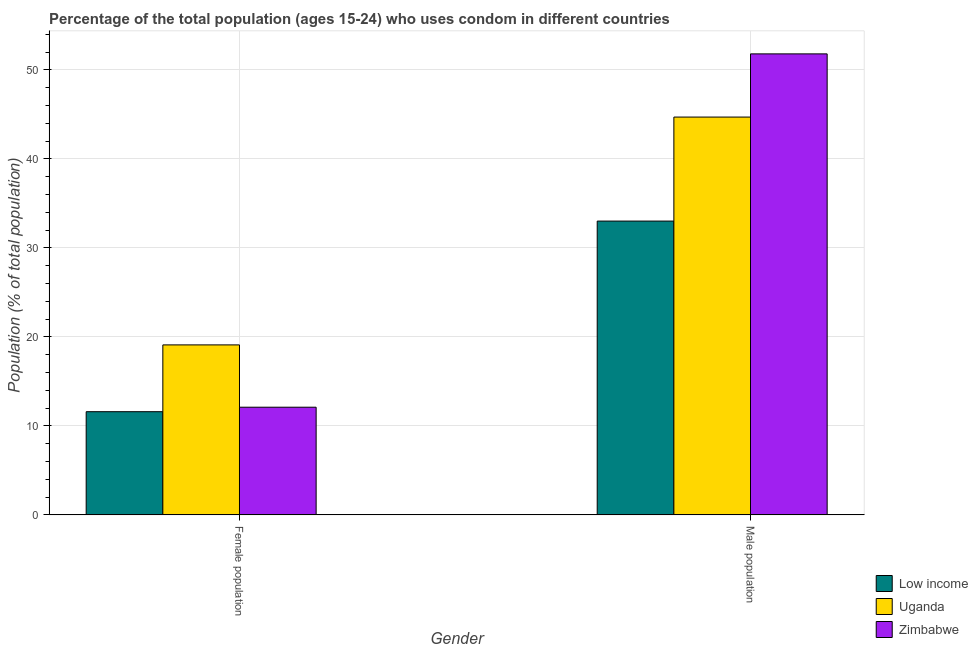How many groups of bars are there?
Your answer should be compact. 2. Are the number of bars on each tick of the X-axis equal?
Provide a succinct answer. Yes. How many bars are there on the 1st tick from the right?
Provide a short and direct response. 3. What is the label of the 1st group of bars from the left?
Offer a terse response. Female population. Across all countries, what is the maximum male population?
Make the answer very short. 51.8. Across all countries, what is the minimum female population?
Ensure brevity in your answer.  11.6. In which country was the male population maximum?
Provide a short and direct response. Zimbabwe. In which country was the male population minimum?
Provide a succinct answer. Low income. What is the total female population in the graph?
Give a very brief answer. 42.8. What is the difference between the female population in Low income and that in Zimbabwe?
Ensure brevity in your answer.  -0.5. What is the difference between the female population in Low income and the male population in Uganda?
Offer a very short reply. -33.1. What is the average female population per country?
Offer a terse response. 14.27. What is the difference between the female population and male population in Low income?
Ensure brevity in your answer.  -21.42. In how many countries, is the female population greater than 44 %?
Ensure brevity in your answer.  0. What is the ratio of the female population in Zimbabwe to that in Uganda?
Give a very brief answer. 0.63. Is the female population in Low income less than that in Zimbabwe?
Give a very brief answer. Yes. What does the 3rd bar from the left in Female population represents?
Your answer should be very brief. Zimbabwe. Are all the bars in the graph horizontal?
Your response must be concise. No. How many countries are there in the graph?
Offer a terse response. 3. What is the difference between two consecutive major ticks on the Y-axis?
Provide a short and direct response. 10. Does the graph contain any zero values?
Your answer should be compact. No. Where does the legend appear in the graph?
Make the answer very short. Bottom right. How are the legend labels stacked?
Your response must be concise. Vertical. What is the title of the graph?
Offer a very short reply. Percentage of the total population (ages 15-24) who uses condom in different countries. Does "Aruba" appear as one of the legend labels in the graph?
Provide a short and direct response. No. What is the label or title of the Y-axis?
Provide a short and direct response. Population (% of total population) . What is the Population (% of total population)  in Low income in Female population?
Offer a terse response. 11.6. What is the Population (% of total population)  of Low income in Male population?
Your answer should be very brief. 33.01. What is the Population (% of total population)  in Uganda in Male population?
Offer a very short reply. 44.7. What is the Population (% of total population)  in Zimbabwe in Male population?
Ensure brevity in your answer.  51.8. Across all Gender, what is the maximum Population (% of total population)  of Low income?
Your answer should be very brief. 33.01. Across all Gender, what is the maximum Population (% of total population)  of Uganda?
Ensure brevity in your answer.  44.7. Across all Gender, what is the maximum Population (% of total population)  in Zimbabwe?
Give a very brief answer. 51.8. Across all Gender, what is the minimum Population (% of total population)  of Low income?
Provide a succinct answer. 11.6. Across all Gender, what is the minimum Population (% of total population)  in Uganda?
Keep it short and to the point. 19.1. Across all Gender, what is the minimum Population (% of total population)  of Zimbabwe?
Offer a terse response. 12.1. What is the total Population (% of total population)  of Low income in the graph?
Give a very brief answer. 44.61. What is the total Population (% of total population)  in Uganda in the graph?
Your response must be concise. 63.8. What is the total Population (% of total population)  in Zimbabwe in the graph?
Provide a short and direct response. 63.9. What is the difference between the Population (% of total population)  in Low income in Female population and that in Male population?
Your answer should be very brief. -21.42. What is the difference between the Population (% of total population)  of Uganda in Female population and that in Male population?
Provide a short and direct response. -25.6. What is the difference between the Population (% of total population)  of Zimbabwe in Female population and that in Male population?
Keep it short and to the point. -39.7. What is the difference between the Population (% of total population)  in Low income in Female population and the Population (% of total population)  in Uganda in Male population?
Keep it short and to the point. -33.1. What is the difference between the Population (% of total population)  of Low income in Female population and the Population (% of total population)  of Zimbabwe in Male population?
Provide a short and direct response. -40.2. What is the difference between the Population (% of total population)  of Uganda in Female population and the Population (% of total population)  of Zimbabwe in Male population?
Provide a short and direct response. -32.7. What is the average Population (% of total population)  of Low income per Gender?
Provide a short and direct response. 22.3. What is the average Population (% of total population)  of Uganda per Gender?
Offer a very short reply. 31.9. What is the average Population (% of total population)  in Zimbabwe per Gender?
Keep it short and to the point. 31.95. What is the difference between the Population (% of total population)  in Low income and Population (% of total population)  in Uganda in Female population?
Keep it short and to the point. -7.5. What is the difference between the Population (% of total population)  of Low income and Population (% of total population)  of Zimbabwe in Female population?
Ensure brevity in your answer.  -0.5. What is the difference between the Population (% of total population)  in Uganda and Population (% of total population)  in Zimbabwe in Female population?
Provide a succinct answer. 7. What is the difference between the Population (% of total population)  in Low income and Population (% of total population)  in Uganda in Male population?
Your response must be concise. -11.69. What is the difference between the Population (% of total population)  in Low income and Population (% of total population)  in Zimbabwe in Male population?
Make the answer very short. -18.79. What is the difference between the Population (% of total population)  in Uganda and Population (% of total population)  in Zimbabwe in Male population?
Provide a succinct answer. -7.1. What is the ratio of the Population (% of total population)  of Low income in Female population to that in Male population?
Provide a succinct answer. 0.35. What is the ratio of the Population (% of total population)  of Uganda in Female population to that in Male population?
Your response must be concise. 0.43. What is the ratio of the Population (% of total population)  of Zimbabwe in Female population to that in Male population?
Keep it short and to the point. 0.23. What is the difference between the highest and the second highest Population (% of total population)  in Low income?
Make the answer very short. 21.42. What is the difference between the highest and the second highest Population (% of total population)  in Uganda?
Keep it short and to the point. 25.6. What is the difference between the highest and the second highest Population (% of total population)  in Zimbabwe?
Keep it short and to the point. 39.7. What is the difference between the highest and the lowest Population (% of total population)  in Low income?
Keep it short and to the point. 21.42. What is the difference between the highest and the lowest Population (% of total population)  in Uganda?
Offer a terse response. 25.6. What is the difference between the highest and the lowest Population (% of total population)  in Zimbabwe?
Your answer should be compact. 39.7. 